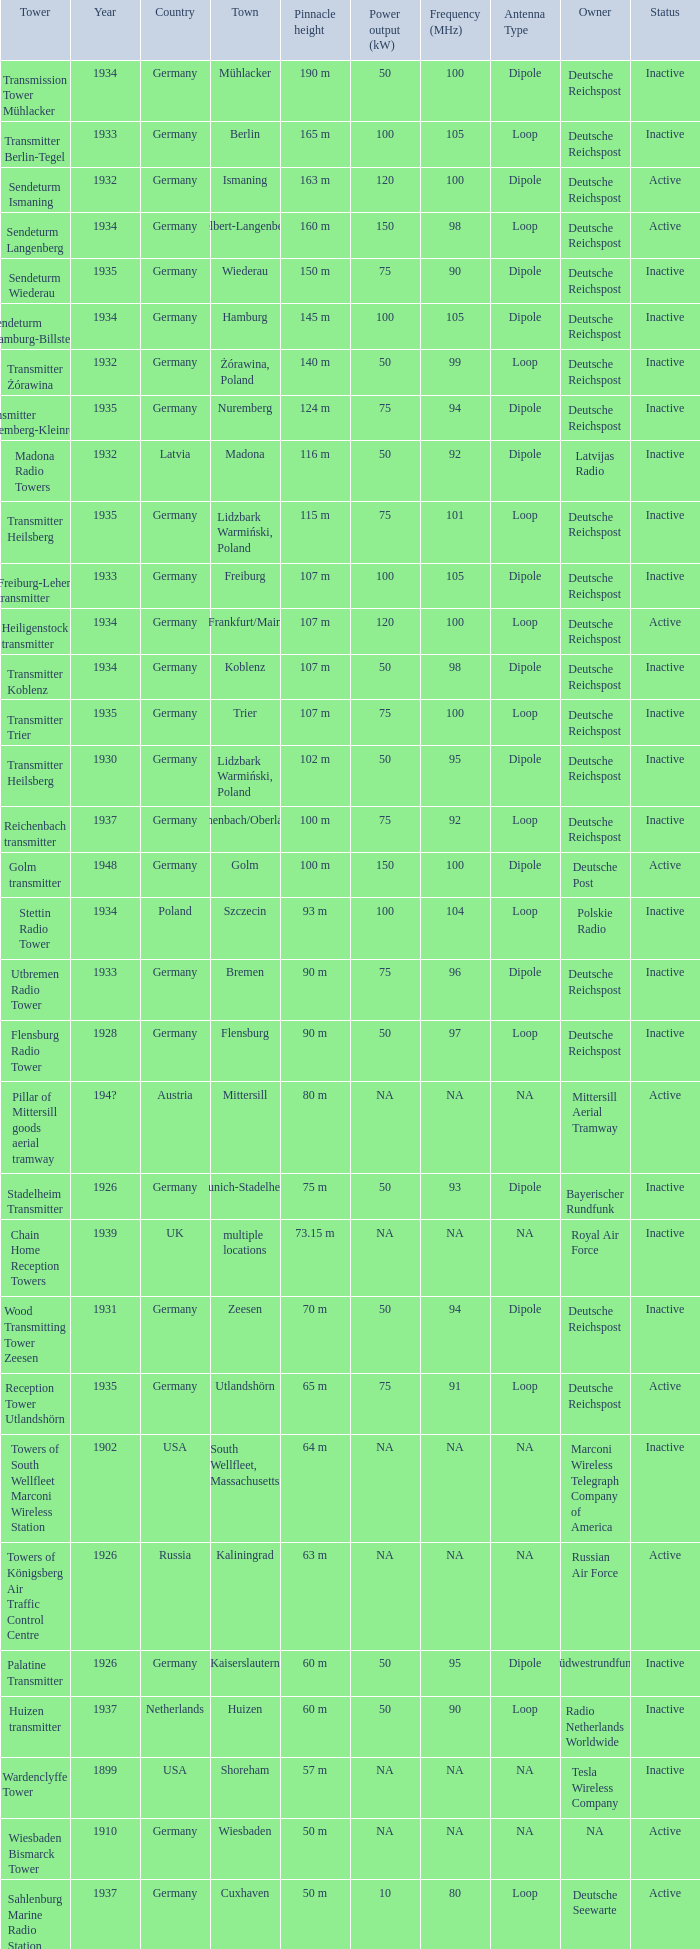Which country had a tower destroyed in 1899? USA. 